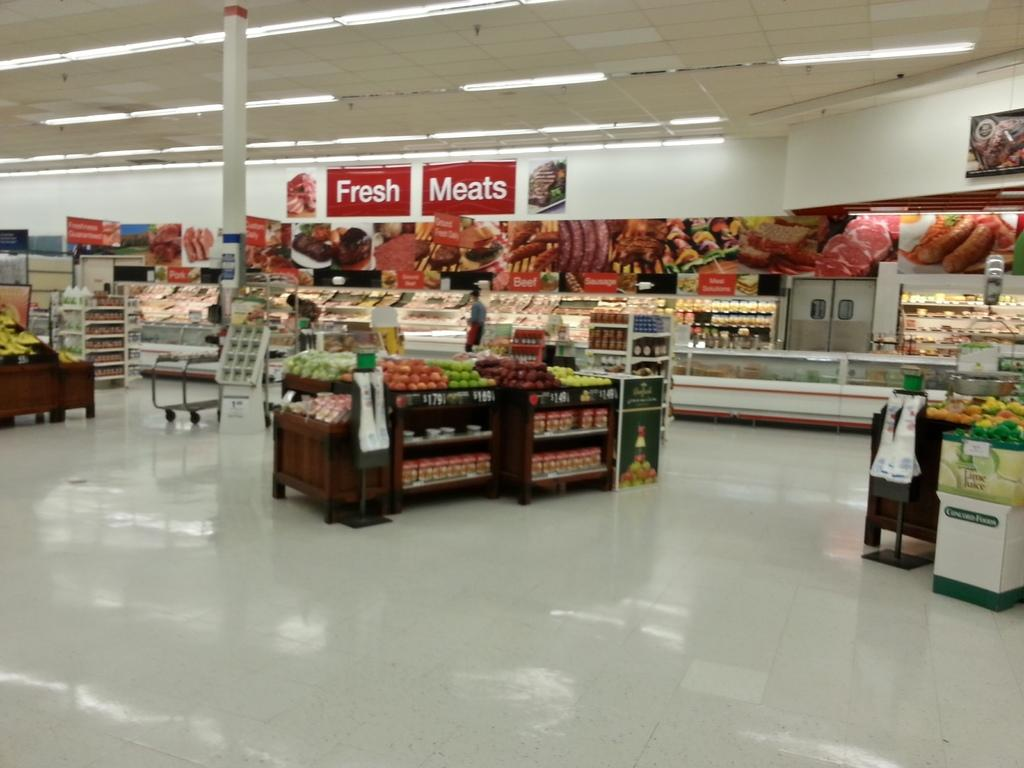<image>
Render a clear and concise summary of the photo. Inside a grocery store with a sign on the wall that says Fresh Meats and pictures of meats below it. 